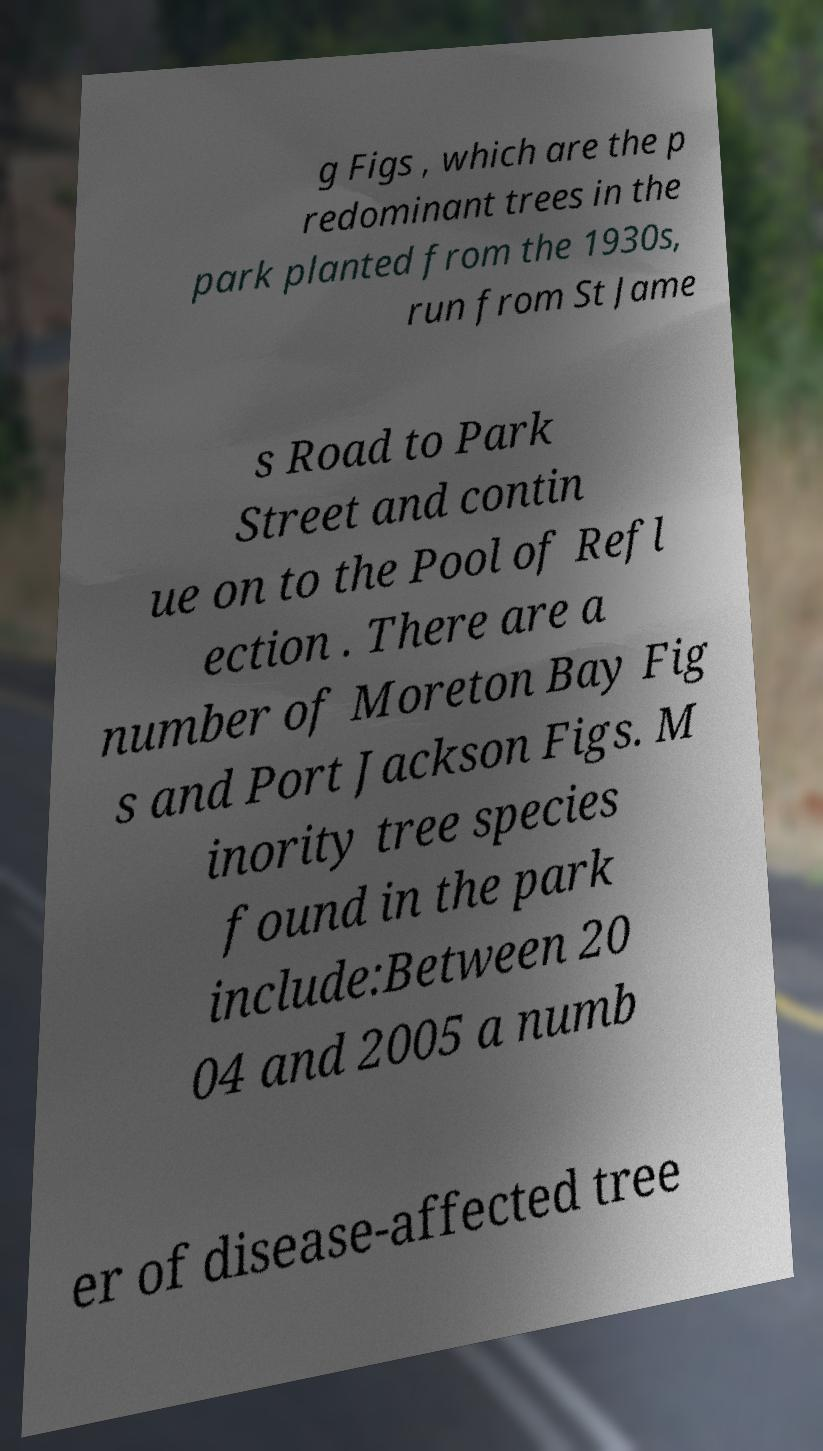Please identify and transcribe the text found in this image. g Figs , which are the p redominant trees in the park planted from the 1930s, run from St Jame s Road to Park Street and contin ue on to the Pool of Refl ection . There are a number of Moreton Bay Fig s and Port Jackson Figs. M inority tree species found in the park include:Between 20 04 and 2005 a numb er of disease-affected tree 